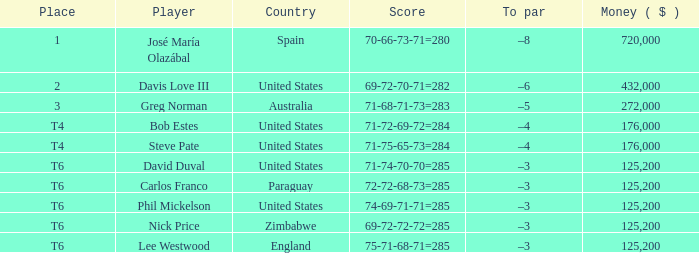What is the average amount of money associated with a score of 69-72-72-72=285? 125200.0. 